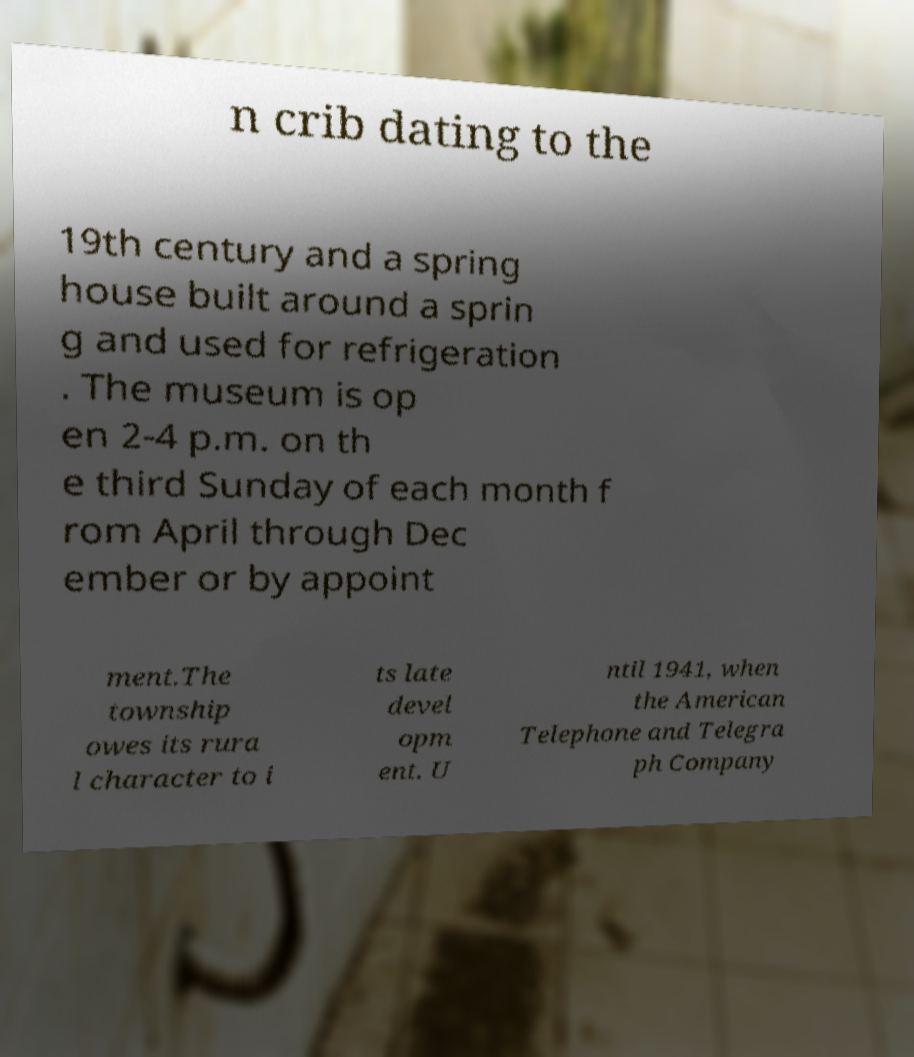Please read and relay the text visible in this image. What does it say? n crib dating to the 19th century and a spring house built around a sprin g and used for refrigeration . The museum is op en 2-4 p.m. on th e third Sunday of each month f rom April through Dec ember or by appoint ment.The township owes its rura l character to i ts late devel opm ent. U ntil 1941, when the American Telephone and Telegra ph Company 